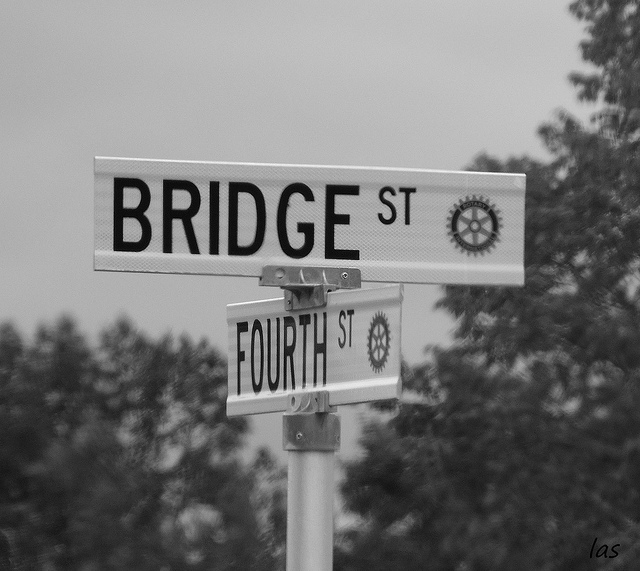<image>What is the symbol on the street signs? I am not sure about the symbol on the street signs. It could be a 'gear', 'cogwheel', 'rotary', 'sun' or 'wheel'. What is the symbol on the street signs? I am not sure what the symbol on the street signs is. It can be seen as 'gear', 'cogwheel', 'rotary', 'sun' or 'wheel'. 